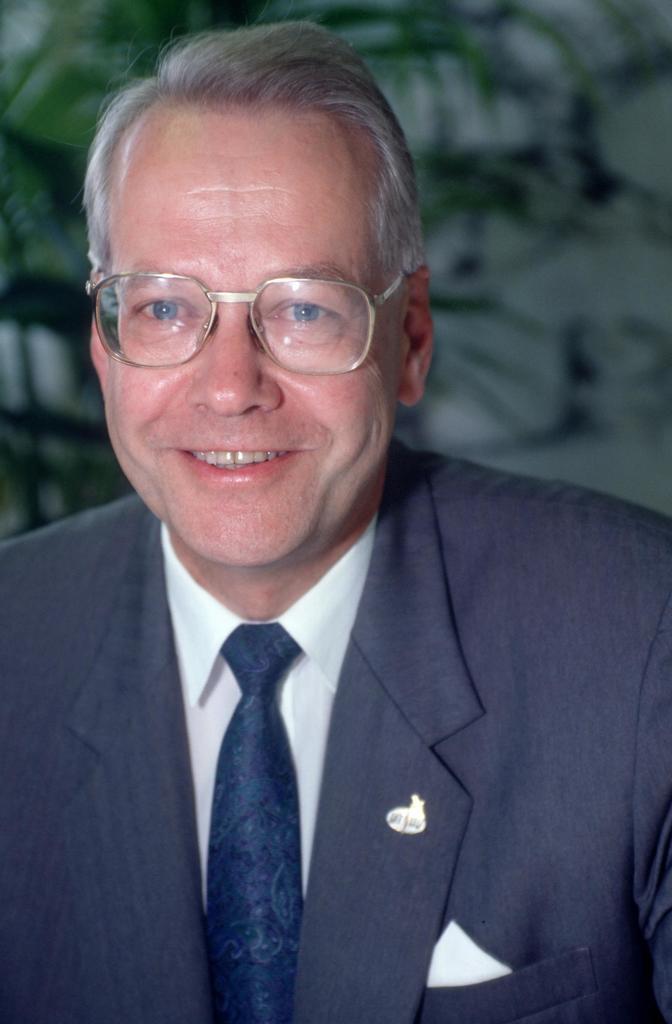Can you describe this image briefly? In this image, we can see an old man in a suit wearing glasses and smiling. Background we can see a blur view. Here we can see plant. 